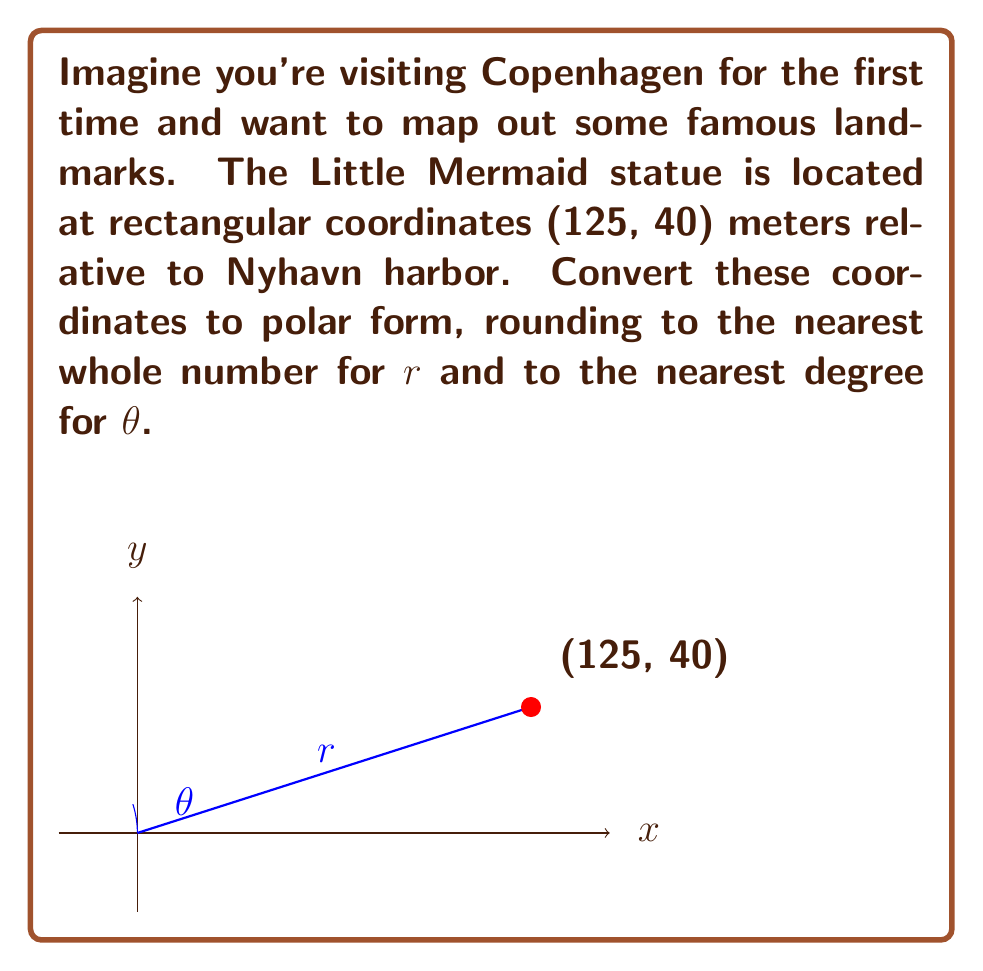Solve this math problem. To convert rectangular coordinates (x, y) to polar coordinates (r, θ), we use these formulas:

1) $r = \sqrt{x^2 + y^2}$
2) $\theta = \tan^{-1}(\frac{y}{x})$

For the Little Mermaid statue at (125, 40):

1) Calculate r:
   $$r = \sqrt{125^2 + 40^2} = \sqrt{15625 + 1600} = \sqrt{17225} \approx 131.24$$
   Rounded to the nearest whole number: r = 131 meters

2) Calculate θ:
   $$\theta = \tan^{-1}(\frac{40}{125}) = \tan^{-1}(0.32) \approx 17.74^\circ$$
   Rounded to the nearest degree: θ = 18°

Note: Since both x and y are positive, the angle is in the first quadrant, so no adjustment is needed.
Answer: (131, 18°) 